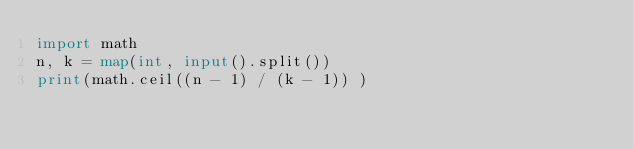Convert code to text. <code><loc_0><loc_0><loc_500><loc_500><_Python_>import math 
n, k = map(int, input().split())
print(math.ceil((n - 1) / (k - 1)) )</code> 